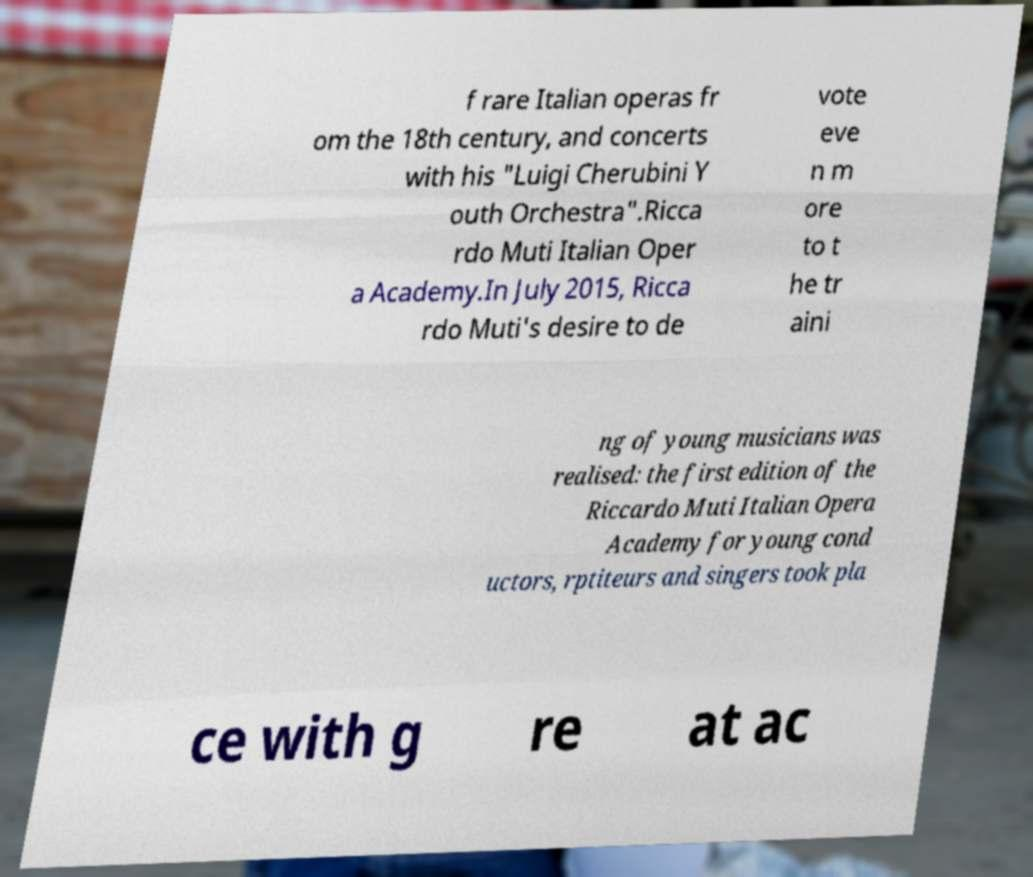Please read and relay the text visible in this image. What does it say? f rare Italian operas fr om the 18th century, and concerts with his "Luigi Cherubini Y outh Orchestra".Ricca rdo Muti Italian Oper a Academy.In July 2015, Ricca rdo Muti's desire to de vote eve n m ore to t he tr aini ng of young musicians was realised: the first edition of the Riccardo Muti Italian Opera Academy for young cond uctors, rptiteurs and singers took pla ce with g re at ac 